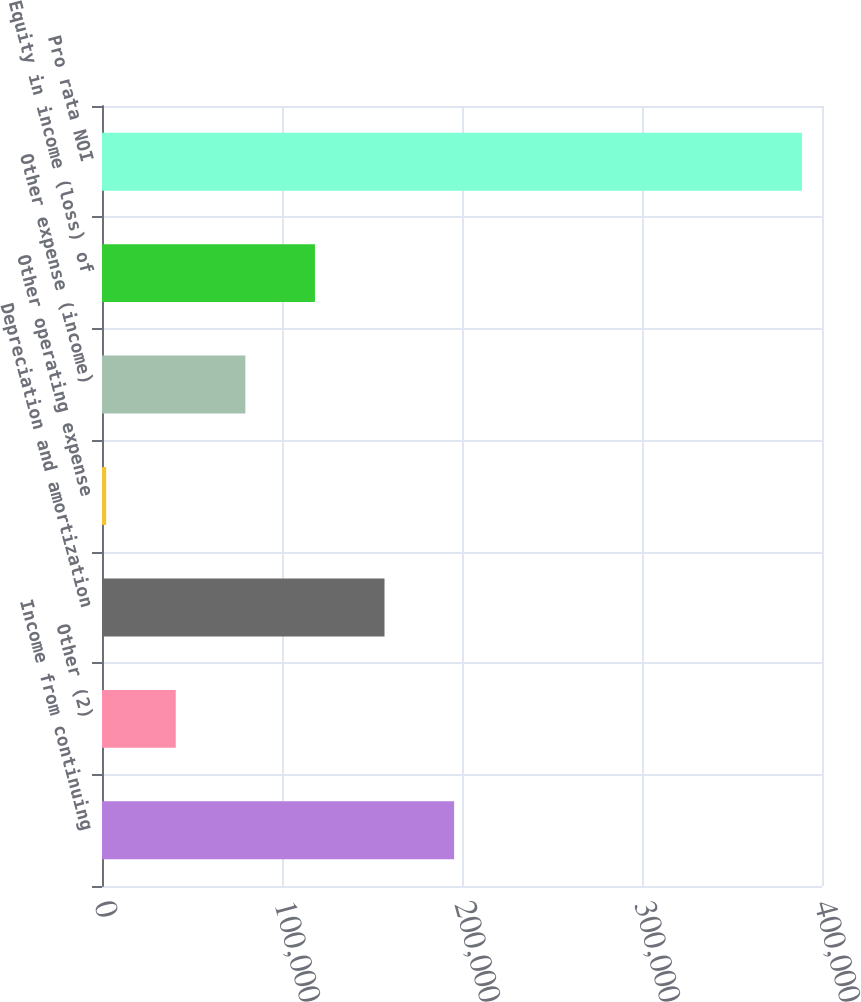Convert chart. <chart><loc_0><loc_0><loc_500><loc_500><bar_chart><fcel>Income from continuing<fcel>Other (2)<fcel>Depreciation and amortization<fcel>Other operating expense<fcel>Other expense (income)<fcel>Equity in income (loss) of<fcel>Pro rata NOI<nl><fcel>195614<fcel>40976.5<fcel>156955<fcel>2317<fcel>79636<fcel>118296<fcel>388912<nl></chart> 